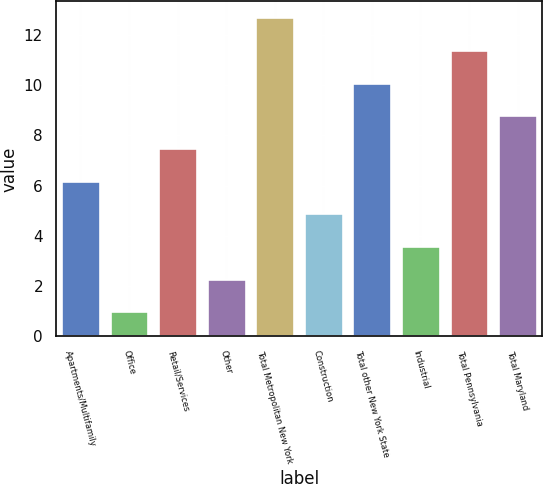Convert chart. <chart><loc_0><loc_0><loc_500><loc_500><bar_chart><fcel>Apartments/Multifamily<fcel>Office<fcel>Retail/Services<fcel>Other<fcel>Total Metropolitan New York<fcel>Construction<fcel>Total other New York State<fcel>Industrial<fcel>Total Pennsylvania<fcel>Total Maryland<nl><fcel>6.2<fcel>1<fcel>7.5<fcel>2.3<fcel>12.7<fcel>4.9<fcel>10.1<fcel>3.6<fcel>11.4<fcel>8.8<nl></chart> 